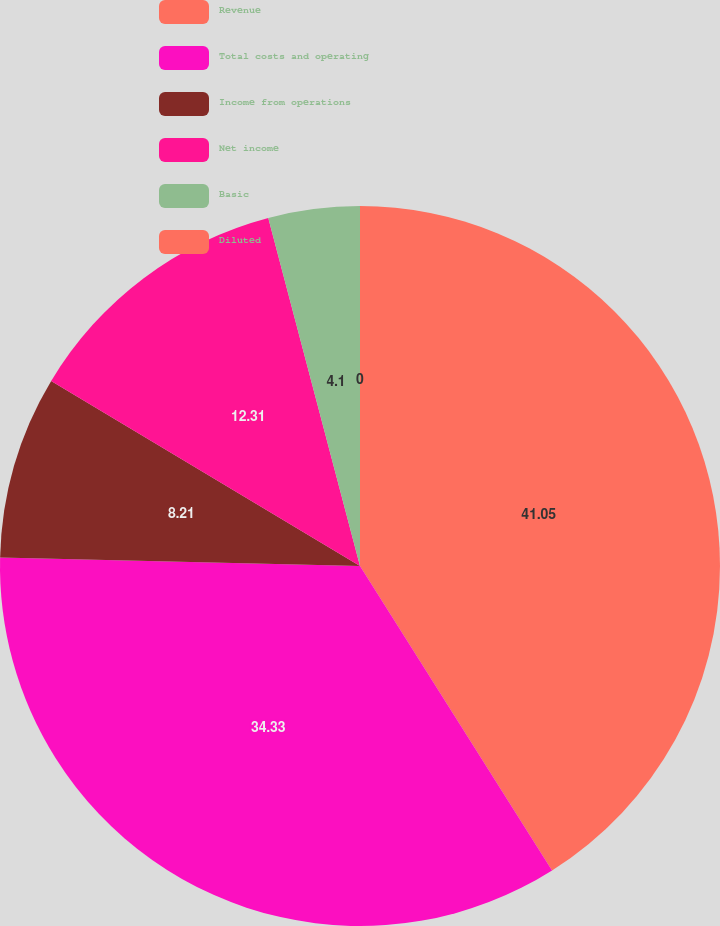Convert chart. <chart><loc_0><loc_0><loc_500><loc_500><pie_chart><fcel>Revenue<fcel>Total costs and operating<fcel>Income from operations<fcel>Net income<fcel>Basic<fcel>Diluted<nl><fcel>41.04%<fcel>34.33%<fcel>8.21%<fcel>12.31%<fcel>4.1%<fcel>0.0%<nl></chart> 